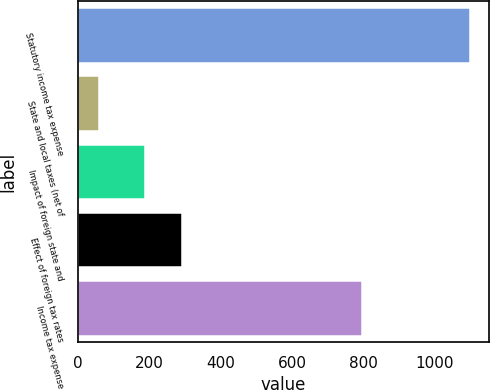Convert chart. <chart><loc_0><loc_0><loc_500><loc_500><bar_chart><fcel>Statutory income tax expense<fcel>State and local taxes (net of<fcel>Impact of foreign state and<fcel>Effect of foreign tax rates<fcel>Income tax expense<nl><fcel>1097<fcel>59<fcel>188<fcel>291.8<fcel>796<nl></chart> 